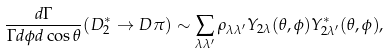Convert formula to latex. <formula><loc_0><loc_0><loc_500><loc_500>\frac { d \Gamma } { \Gamma d \phi d \cos \theta } ( D _ { 2 } ^ { * } \to D \pi ) \sim \sum _ { \lambda \lambda ^ { \prime } } \rho _ { \lambda \lambda ^ { \prime } } Y _ { 2 \lambda } ( \theta , \phi ) Y _ { 2 \lambda ^ { \prime } } ^ { * } ( \theta , \phi ) ,</formula> 